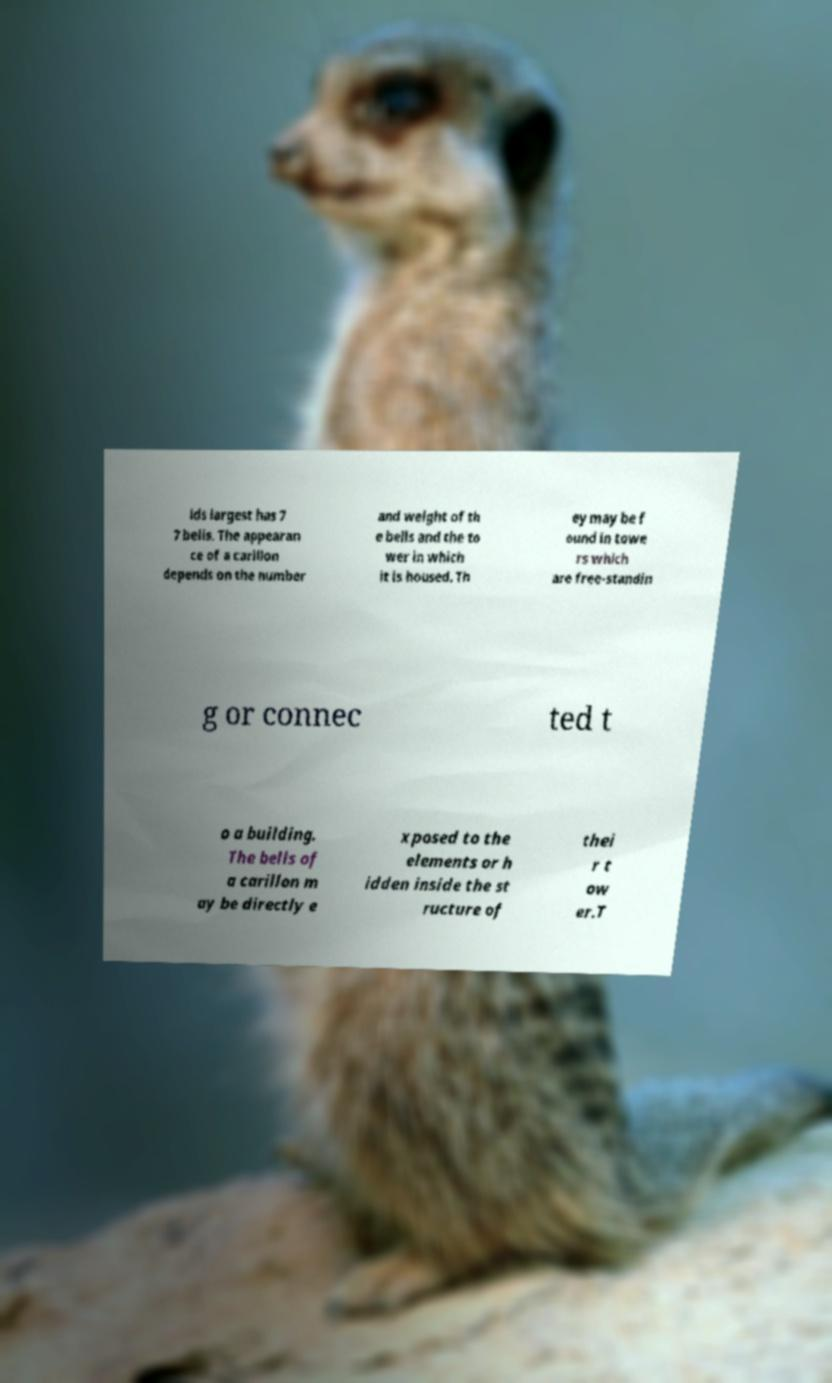Please read and relay the text visible in this image. What does it say? lds largest has 7 7 bells. The appearan ce of a carillon depends on the number and weight of th e bells and the to wer in which it is housed. Th ey may be f ound in towe rs which are free-standin g or connec ted t o a building. The bells of a carillon m ay be directly e xposed to the elements or h idden inside the st ructure of thei r t ow er.T 